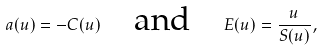Convert formula to latex. <formula><loc_0><loc_0><loc_500><loc_500>a ( u ) = - C ( u ) \quad \text {and} \quad E ( u ) = \frac { u } { S ( u ) } ,</formula> 